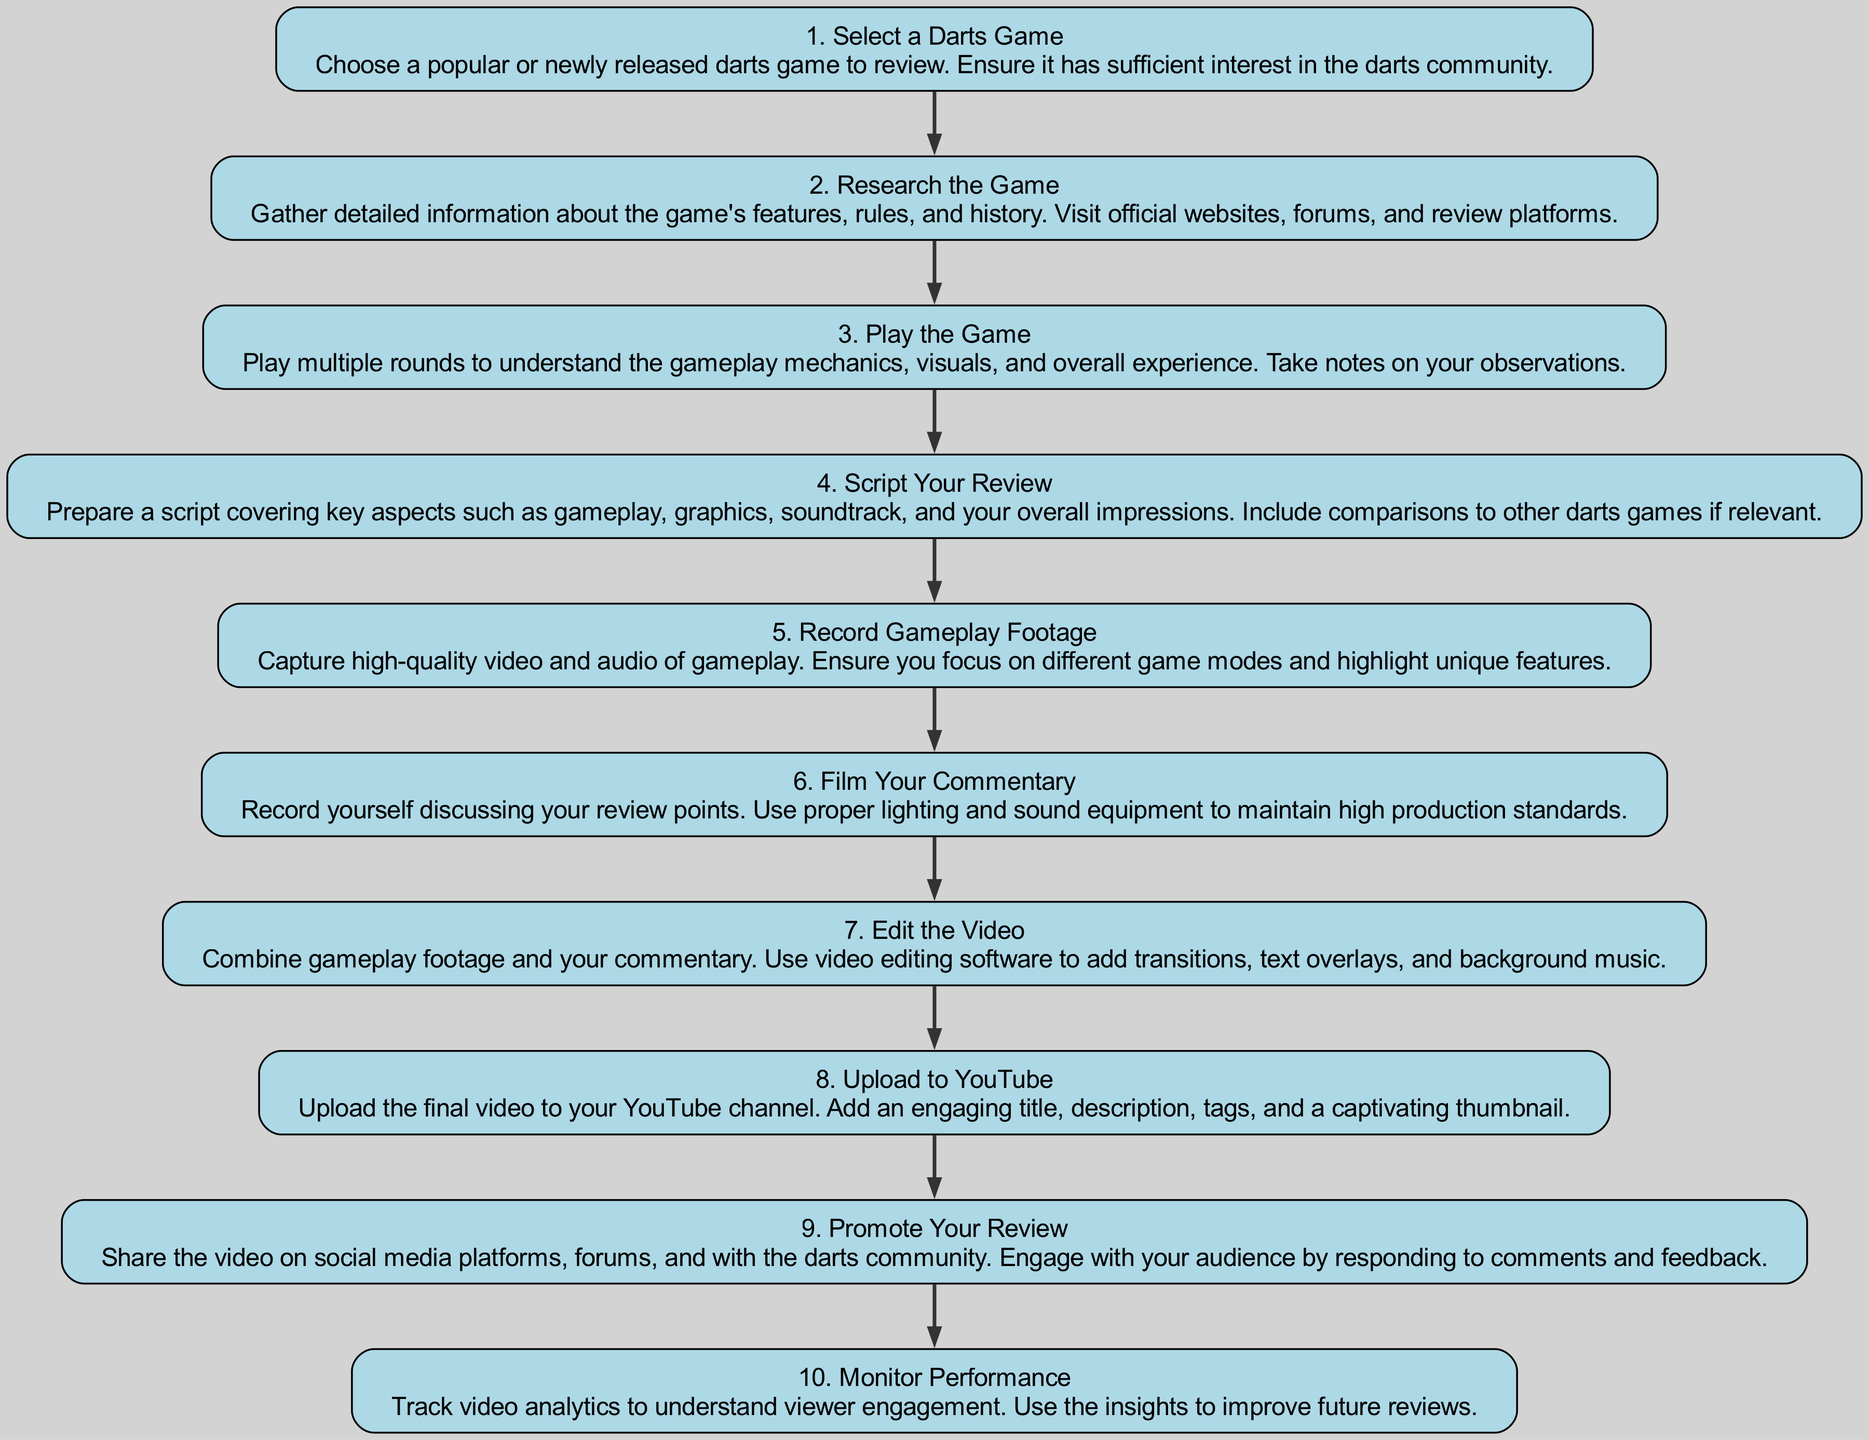What is the first step in the review process? The first node in the flow chart is labeled as "1. Select a Darts Game," which indicates that this is the starting point of the process.
Answer: Select a Darts Game How many total steps are there in the process? By counting all the individual nodes listed in the diagram, we see that there are ten distinct steps that outline the process of creating a darts game review.
Answer: 10 What is the last step in the flow chart? The last node in the flow chart is "10. Monitor Performance," which signifies the final action in the process of creating the review.
Answer: Monitor Performance What is step 4 about? Referring to the node labeled "4. Script Your Review," we can determine that this step involves preparing a script that discusses key aspects of the game, such as gameplay and graphics.
Answer: Script Your Review What step follows the recording of gameplay footage? The diagram shows a direct connection from "5. Record Gameplay Footage" to "6. Film Your Commentary," indicating that filming commentary is the next action required in the review process.
Answer: Film Your Commentary What is the relationship between the second and third steps? The second step, "Research the Game," is directly followed by "3. Play the Game," which means that after researching, the next logical action is to play the game to gather firsthand experience.
Answer: Play the Game In which step should you analyze video analytics? The final step, "10. Monitor Performance," specifically mentions tracking video analytics to assess viewer engagement, indicating that this is where analysis occurs.
Answer: Monitor Performance Which step involves social media engagement? Step "9. Promote Your Review" explicitly mentions sharing the video on social media and engaging with the audience, indicating this step focuses on outreach and interaction.
Answer: Promote Your Review What type of content does step 6 focus on? The node "6. Film Your Commentary" indicates that this part of the process is focused on recording commentary, specifically discussing review points about the game.
Answer: Commentary 